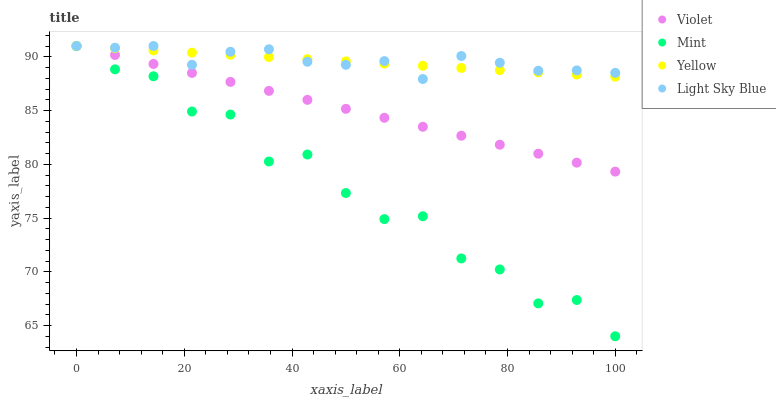Does Mint have the minimum area under the curve?
Answer yes or no. Yes. Does Light Sky Blue have the maximum area under the curve?
Answer yes or no. Yes. Does Yellow have the minimum area under the curve?
Answer yes or no. No. Does Yellow have the maximum area under the curve?
Answer yes or no. No. Is Yellow the smoothest?
Answer yes or no. Yes. Is Mint the roughest?
Answer yes or no. Yes. Is Mint the smoothest?
Answer yes or no. No. Is Yellow the roughest?
Answer yes or no. No. Does Mint have the lowest value?
Answer yes or no. Yes. Does Yellow have the lowest value?
Answer yes or no. No. Does Violet have the highest value?
Answer yes or no. Yes. Does Light Sky Blue intersect Violet?
Answer yes or no. Yes. Is Light Sky Blue less than Violet?
Answer yes or no. No. Is Light Sky Blue greater than Violet?
Answer yes or no. No. 